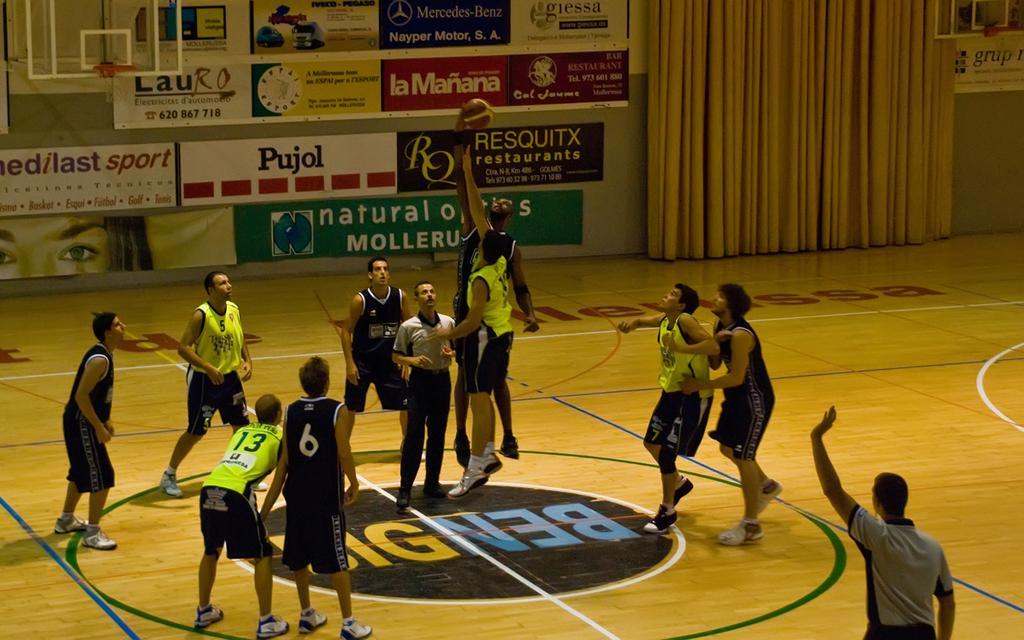Please provide a concise description of this image. In this image few players are playing basketball. Here there is a basket. In the background there are posters, curtains. 